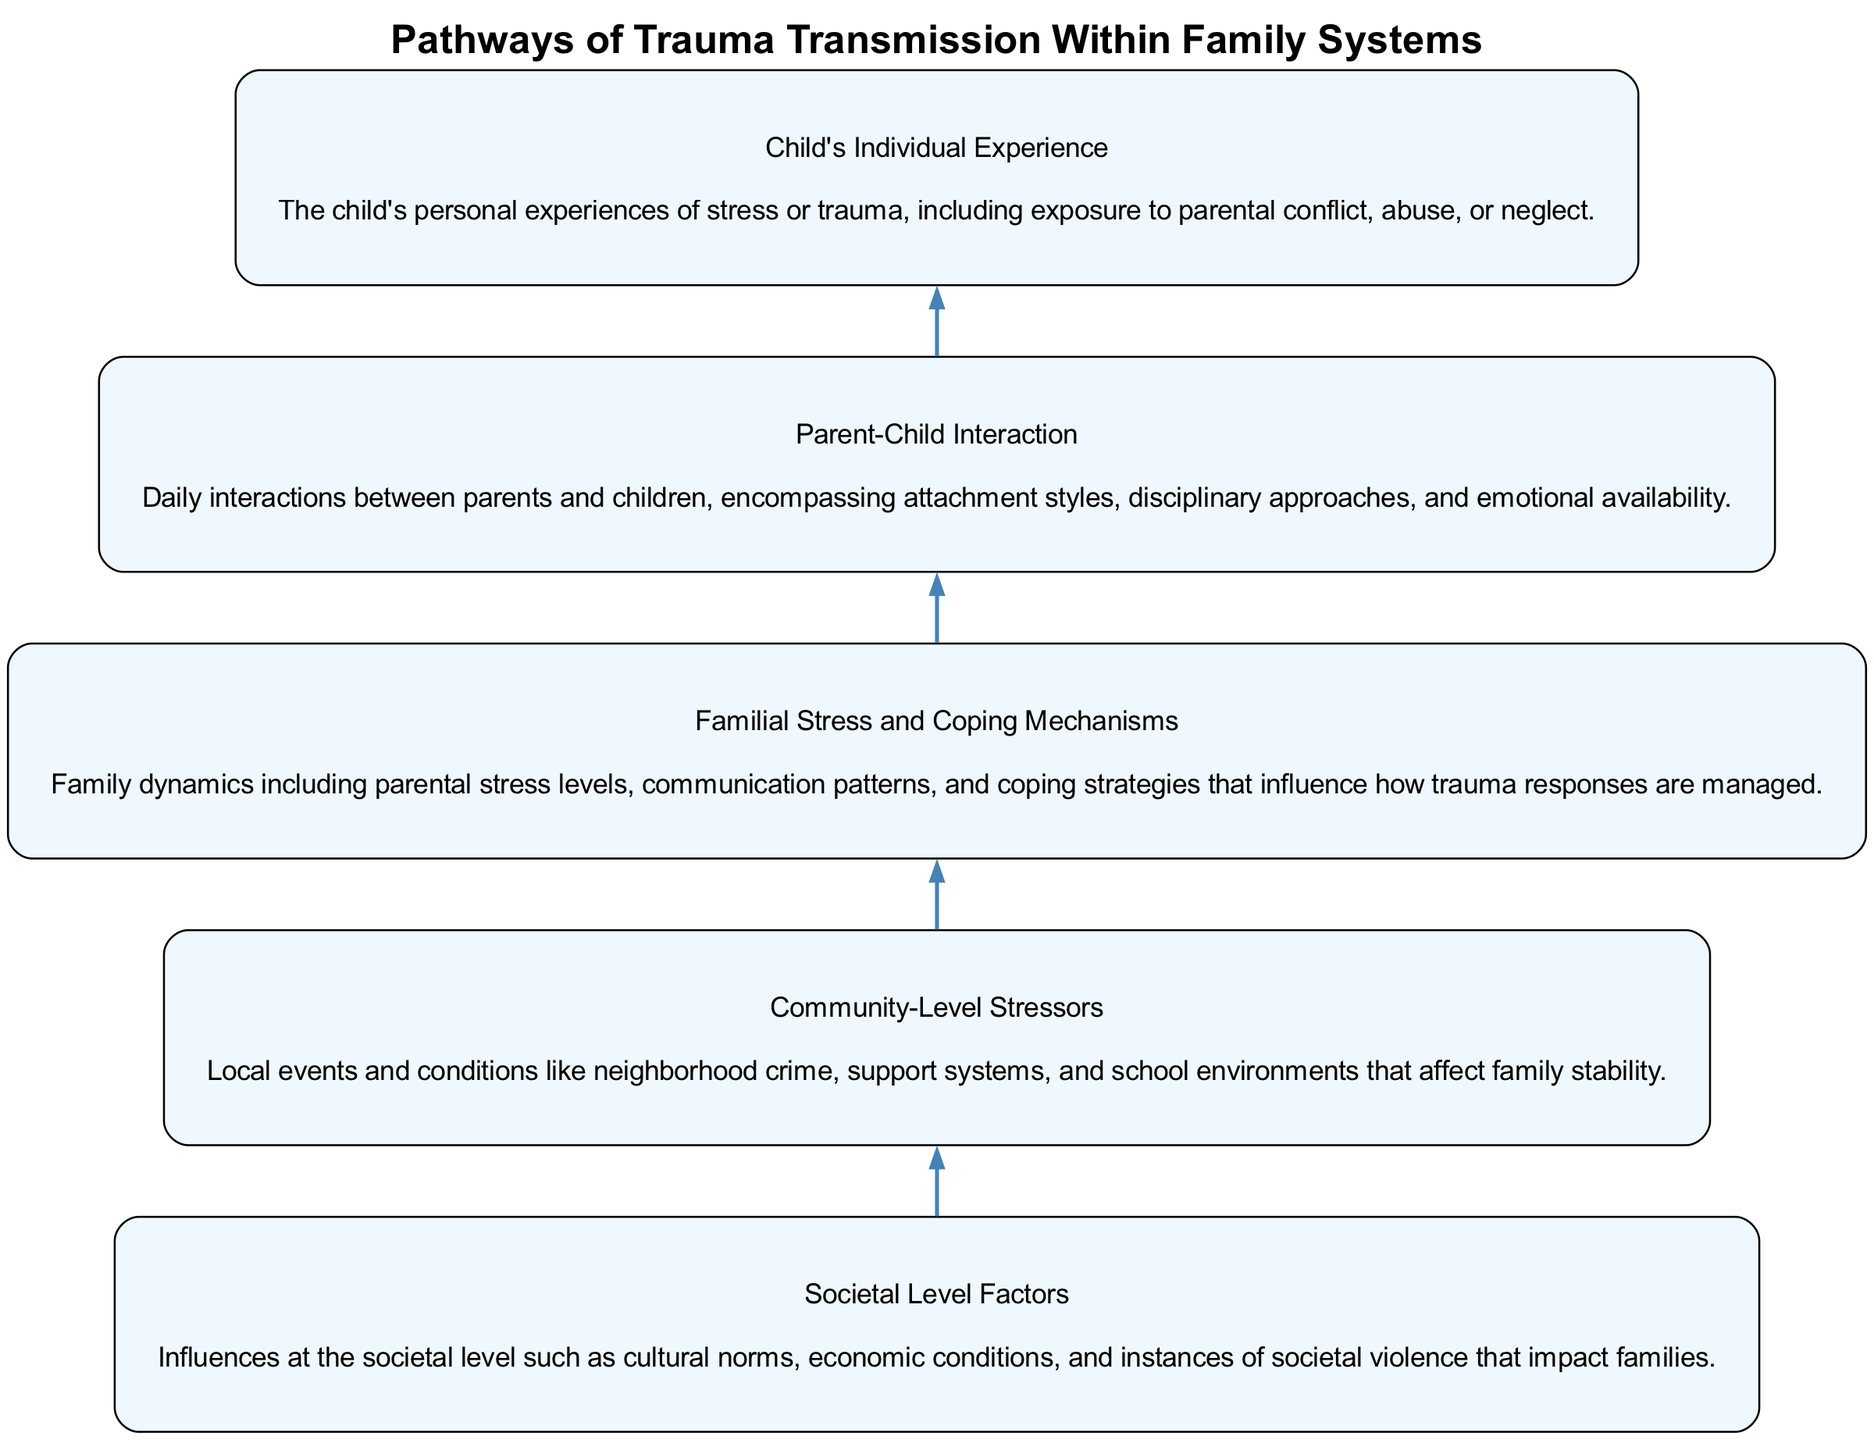What is the highest level factor in the diagram? The highest level factor in the flow chart is "Societal Level Factors," which is the topmost node influencing the others.
Answer: Societal Level Factors How many nodes are present in the diagram? The diagram features five distinct nodes, each representing different elements related to trauma transmission.
Answer: 5 What kind of stressors are depicted at the community level? The node specifying "Community-Level Stressors" emphasizes local events such as neighborhood crime and support systems that impact families.
Answer: Local events What is the direct influence of "Familial Stress and Coping Mechanisms"? "Familial Stress and Coping Mechanisms" directly influences "Parent-Child Interaction," highlighting how family dynamics affect interactions.
Answer: Parent-Child Interaction What node is affected by "Child's Individual Experience"? The "Child's Individual Experience" impacts the "Parent-Child Interaction," showing how the child's experiences shape their interactions with parents.
Answer: Parent-Child Interaction Which node is at the bottom of the flow chart? The bottom node of the flow chart is "Child's Individual Experience," indicating it is the focus of the trauma consequences.
Answer: Child's Individual Experience In what direction does the flow of influence go in the diagram? The flow of influence in the diagram moves from the bottom to the top, showing how factors build upon each other.
Answer: Bottom to top How does "Community-Level Stressors" connect with the "Familial Stress and Coping Mechanisms"? "Community-Level Stressors" influences "Familial Stress and Coping Mechanisms," indicating that community events can affect family dynamics.
Answer: Familial Stress and Coping Mechanisms Which two nodes are directly linked in the flow? "Familial Stress and Coping Mechanisms" and "Parent-Child Interaction" are directly linked, showing a straightforward impact between them.
Answer: Parent-Child Interaction 